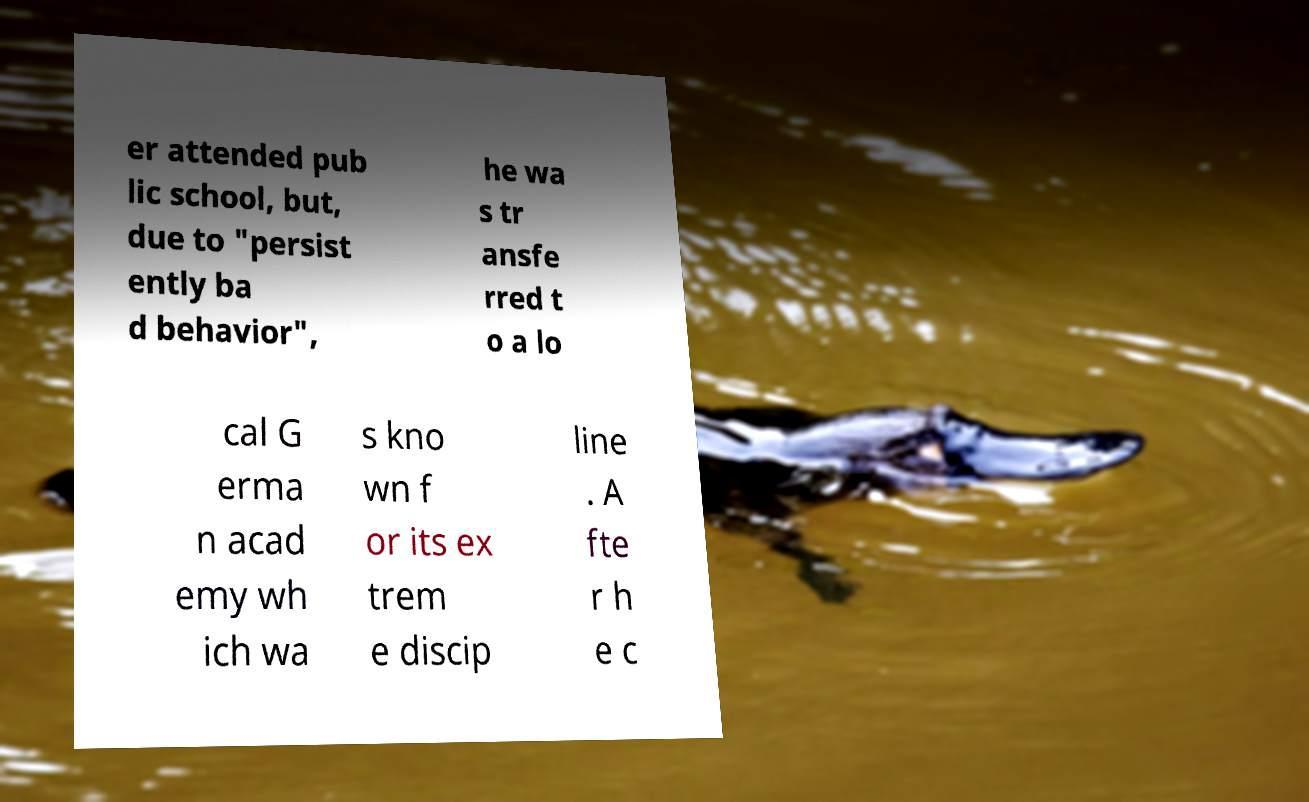I need the written content from this picture converted into text. Can you do that? er attended pub lic school, but, due to "persist ently ba d behavior", he wa s tr ansfe rred t o a lo cal G erma n acad emy wh ich wa s kno wn f or its ex trem e discip line . A fte r h e c 